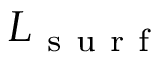<formula> <loc_0><loc_0><loc_500><loc_500>L _ { s u r f }</formula> 